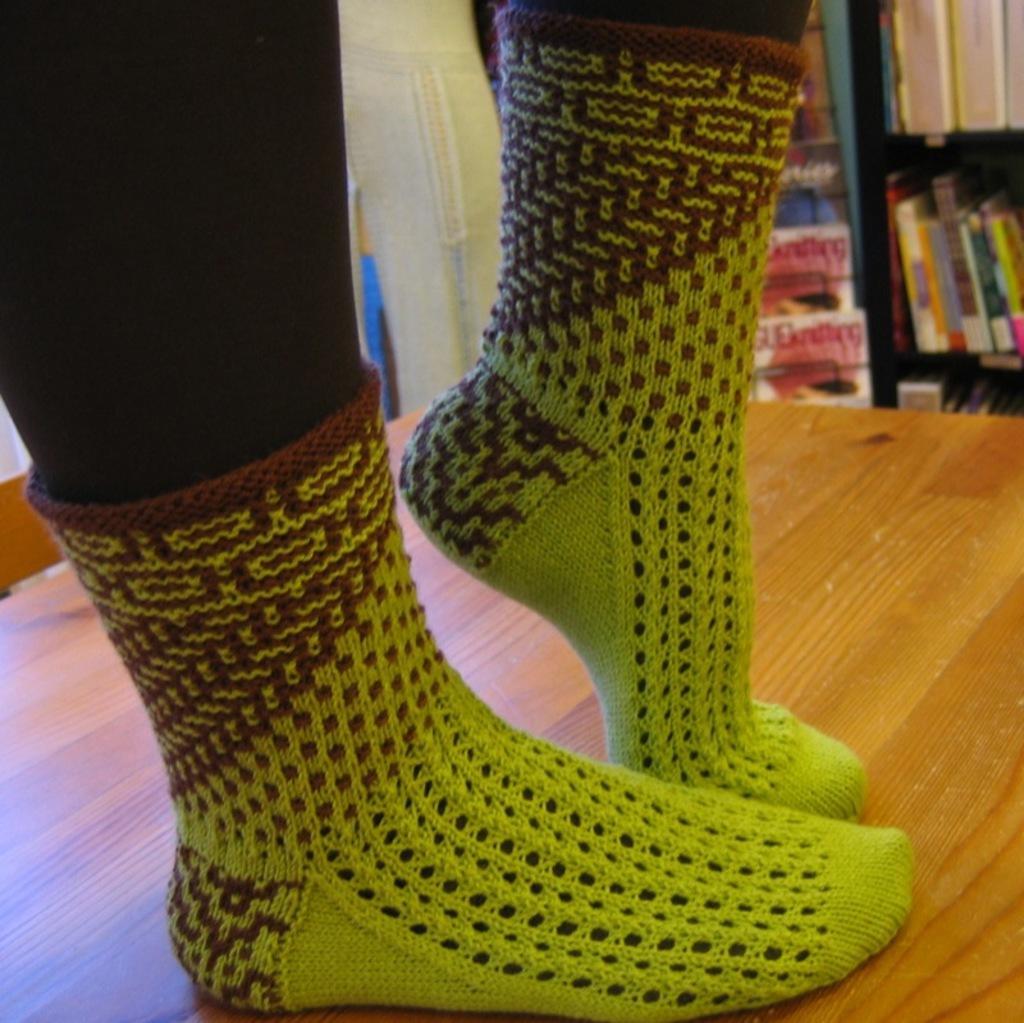In one or two sentences, can you explain what this image depicts? In this image I can see the person's legs and the person is standing on the table. I can see the socks to the legs. In the background I can see the books in the rack. 